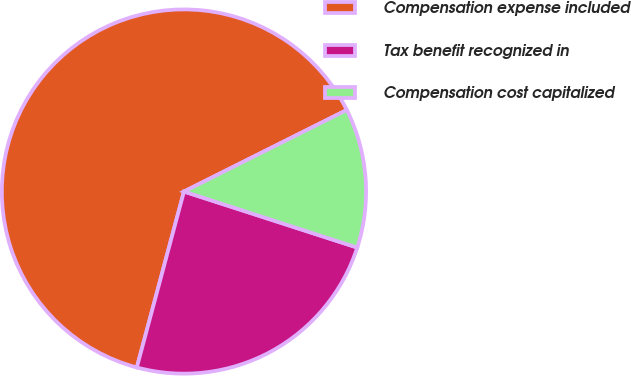Convert chart. <chart><loc_0><loc_0><loc_500><loc_500><pie_chart><fcel>Compensation expense included<fcel>Tax benefit recognized in<fcel>Compensation cost capitalized<nl><fcel>63.44%<fcel>24.19%<fcel>12.37%<nl></chart> 